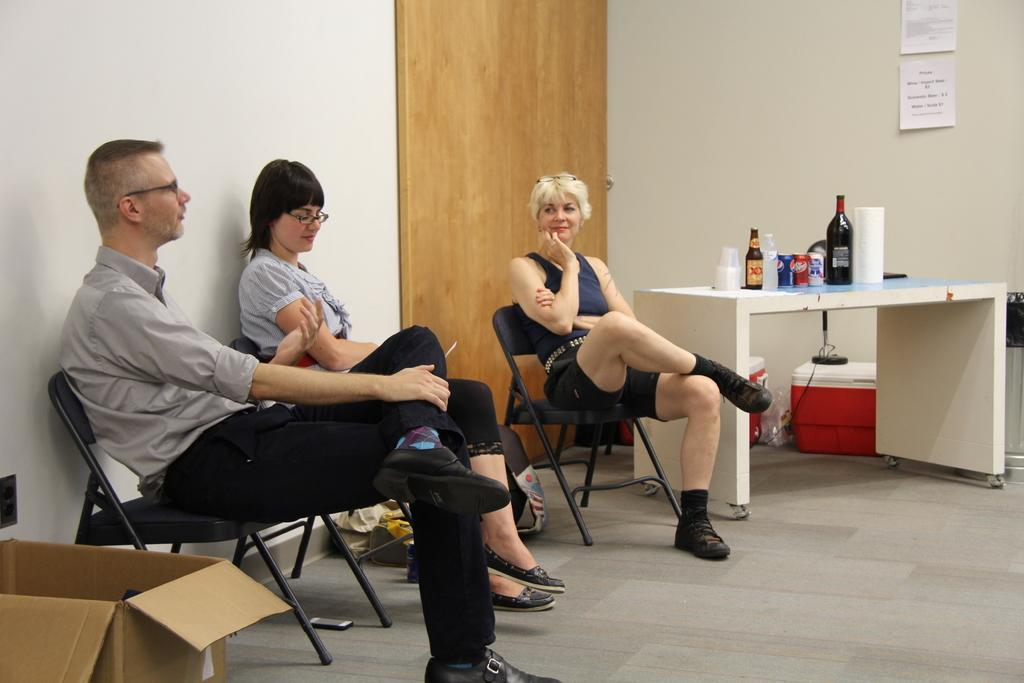What are the people in the image doing? The people in the image are sitting on chairs. What is present in the image besides the people? There is a table in the image. What can be seen on the table? There are bottles on the table. What type of ocean can be seen in the image? There is no ocean present in the image; it features people sitting on chairs and a table with bottles. What is the opinion of the people about the juice in the bottles? There is no information about the people's opinions in the image, as it only shows them sitting on chairs and a table with bottles. 